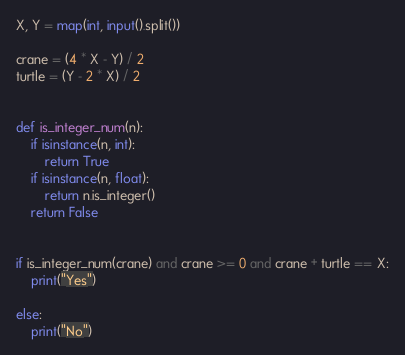Convert code to text. <code><loc_0><loc_0><loc_500><loc_500><_Python_>X, Y = map(int, input().split())

crane = (4 * X - Y) / 2
turtle = (Y - 2 * X) / 2


def is_integer_num(n):
    if isinstance(n, int):
        return True
    if isinstance(n, float):
        return n.is_integer()
    return False


if is_integer_num(crane) and crane >= 0 and crane + turtle == X:
    print("Yes")

else:
    print("No")
</code> 